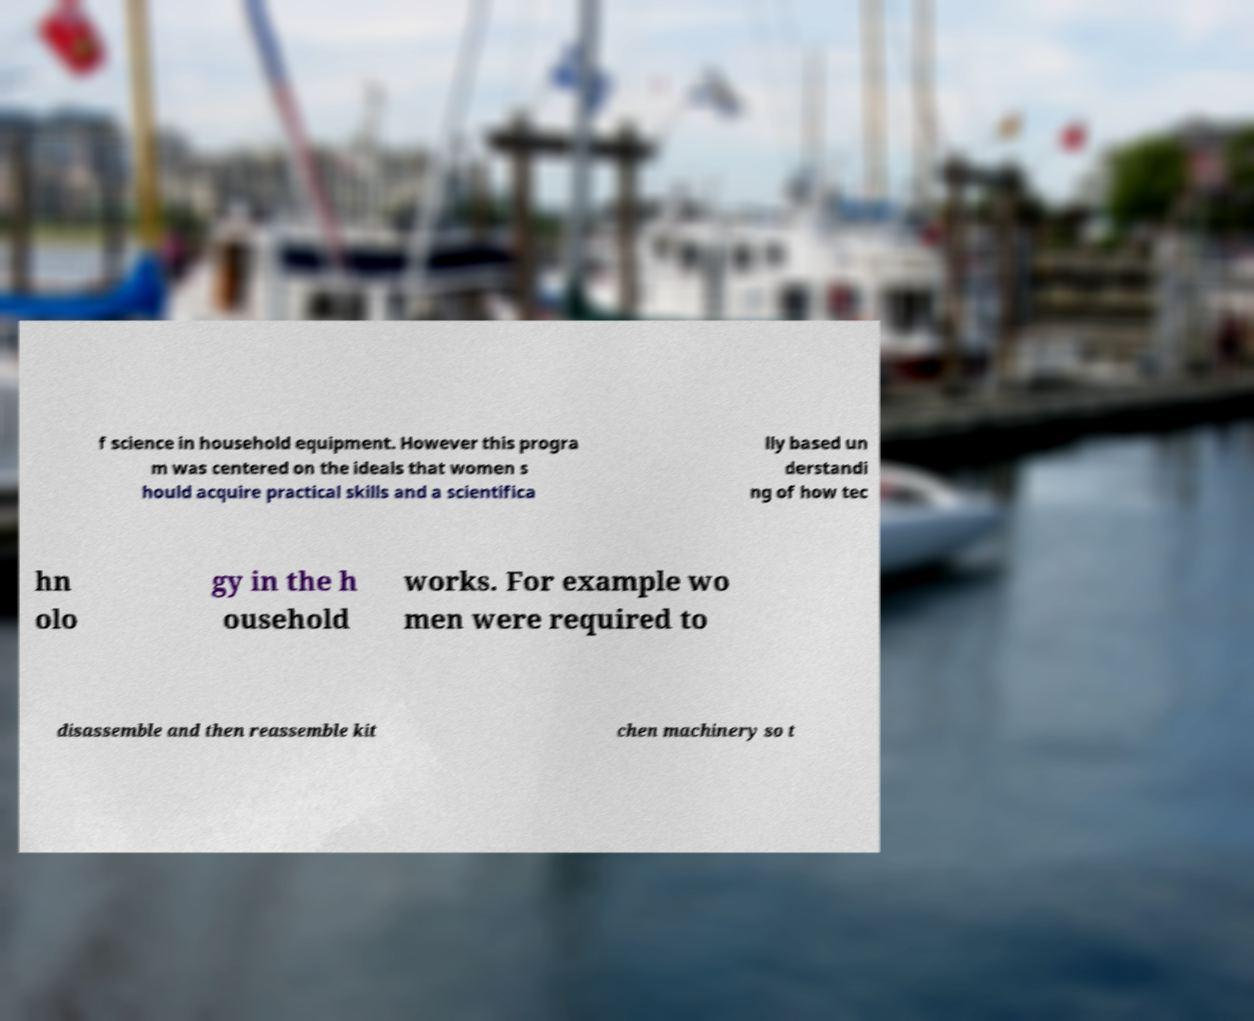Could you assist in decoding the text presented in this image and type it out clearly? f science in household equipment. However this progra m was centered on the ideals that women s hould acquire practical skills and a scientifica lly based un derstandi ng of how tec hn olo gy in the h ousehold works. For example wo men were required to disassemble and then reassemble kit chen machinery so t 